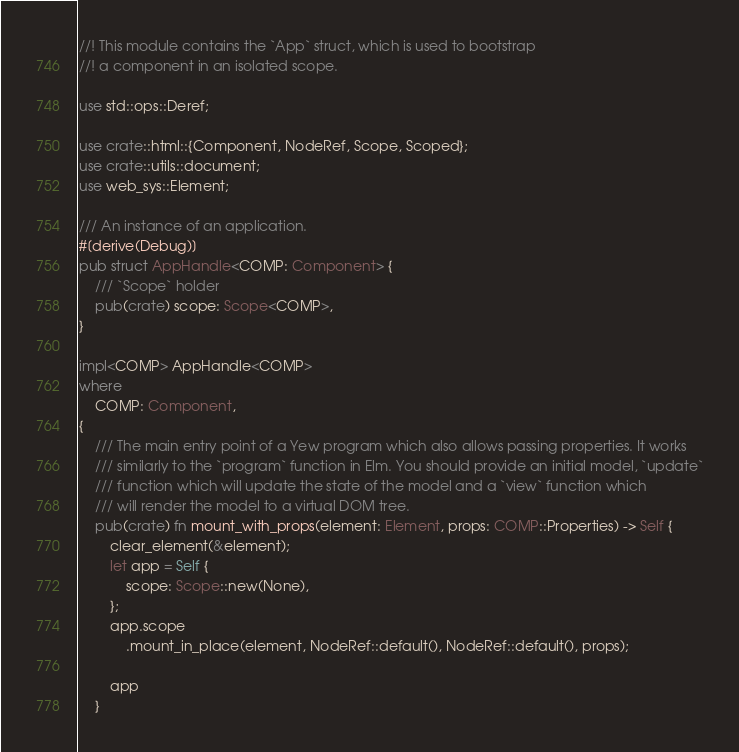Convert code to text. <code><loc_0><loc_0><loc_500><loc_500><_Rust_>//! This module contains the `App` struct, which is used to bootstrap
//! a component in an isolated scope.

use std::ops::Deref;

use crate::html::{Component, NodeRef, Scope, Scoped};
use crate::utils::document;
use web_sys::Element;

/// An instance of an application.
#[derive(Debug)]
pub struct AppHandle<COMP: Component> {
    /// `Scope` holder
    pub(crate) scope: Scope<COMP>,
}

impl<COMP> AppHandle<COMP>
where
    COMP: Component,
{
    /// The main entry point of a Yew program which also allows passing properties. It works
    /// similarly to the `program` function in Elm. You should provide an initial model, `update`
    /// function which will update the state of the model and a `view` function which
    /// will render the model to a virtual DOM tree.
    pub(crate) fn mount_with_props(element: Element, props: COMP::Properties) -> Self {
        clear_element(&element);
        let app = Self {
            scope: Scope::new(None),
        };
        app.scope
            .mount_in_place(element, NodeRef::default(), NodeRef::default(), props);

        app
    }
</code> 